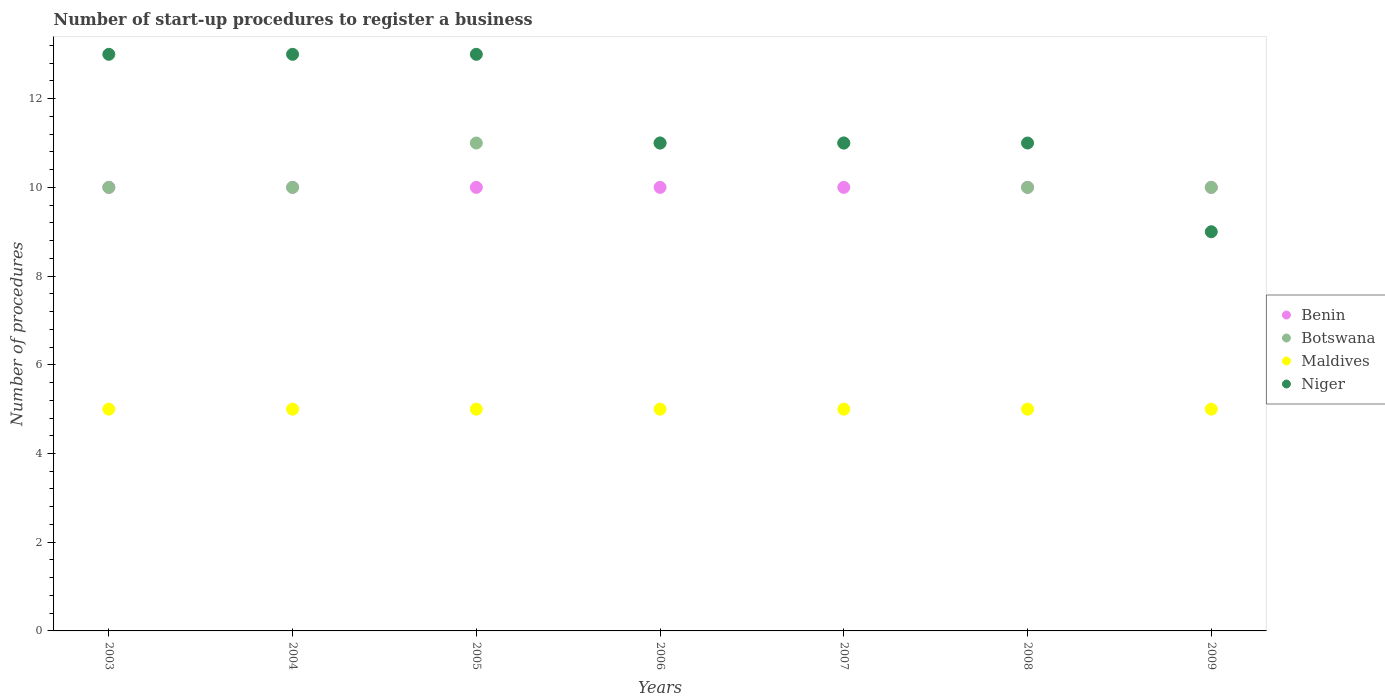Is the number of dotlines equal to the number of legend labels?
Provide a succinct answer. Yes. What is the number of procedures required to register a business in Niger in 2007?
Ensure brevity in your answer.  11. Across all years, what is the maximum number of procedures required to register a business in Niger?
Provide a succinct answer. 13. Across all years, what is the minimum number of procedures required to register a business in Niger?
Offer a terse response. 9. In which year was the number of procedures required to register a business in Maldives maximum?
Your answer should be very brief. 2003. In which year was the number of procedures required to register a business in Maldives minimum?
Provide a short and direct response. 2003. What is the total number of procedures required to register a business in Botswana in the graph?
Provide a short and direct response. 73. What is the difference between the number of procedures required to register a business in Botswana in 2008 and the number of procedures required to register a business in Maldives in 2007?
Provide a short and direct response. 5. What is the average number of procedures required to register a business in Botswana per year?
Your answer should be very brief. 10.43. In the year 2008, what is the difference between the number of procedures required to register a business in Maldives and number of procedures required to register a business in Niger?
Offer a terse response. -6. In how many years, is the number of procedures required to register a business in Maldives greater than 9.2?
Provide a succinct answer. 0. Is the number of procedures required to register a business in Maldives in 2007 less than that in 2009?
Make the answer very short. No. What is the difference between the highest and the lowest number of procedures required to register a business in Benin?
Ensure brevity in your answer.  0. Is it the case that in every year, the sum of the number of procedures required to register a business in Niger and number of procedures required to register a business in Benin  is greater than the number of procedures required to register a business in Maldives?
Ensure brevity in your answer.  Yes. Is the number of procedures required to register a business in Benin strictly greater than the number of procedures required to register a business in Maldives over the years?
Your answer should be very brief. Yes. What is the difference between two consecutive major ticks on the Y-axis?
Provide a succinct answer. 2. Does the graph contain any zero values?
Offer a very short reply. No. Does the graph contain grids?
Ensure brevity in your answer.  No. Where does the legend appear in the graph?
Your answer should be compact. Center right. How many legend labels are there?
Your response must be concise. 4. How are the legend labels stacked?
Provide a succinct answer. Vertical. What is the title of the graph?
Give a very brief answer. Number of start-up procedures to register a business. What is the label or title of the X-axis?
Provide a short and direct response. Years. What is the label or title of the Y-axis?
Offer a very short reply. Number of procedures. What is the Number of procedures of Botswana in 2003?
Give a very brief answer. 10. What is the Number of procedures in Maldives in 2003?
Provide a short and direct response. 5. What is the Number of procedures of Benin in 2004?
Your answer should be very brief. 10. What is the Number of procedures in Maldives in 2004?
Provide a short and direct response. 5. What is the Number of procedures of Benin in 2005?
Provide a short and direct response. 10. What is the Number of procedures in Botswana in 2005?
Ensure brevity in your answer.  11. What is the Number of procedures in Maldives in 2005?
Make the answer very short. 5. What is the Number of procedures in Botswana in 2006?
Give a very brief answer. 11. What is the Number of procedures of Niger in 2006?
Your response must be concise. 11. What is the Number of procedures in Botswana in 2007?
Offer a very short reply. 11. What is the Number of procedures of Maldives in 2007?
Keep it short and to the point. 5. What is the Number of procedures of Benin in 2008?
Make the answer very short. 10. What is the Number of procedures of Niger in 2008?
Your answer should be very brief. 11. What is the Number of procedures in Niger in 2009?
Your response must be concise. 9. Across all years, what is the maximum Number of procedures of Benin?
Ensure brevity in your answer.  10. Across all years, what is the minimum Number of procedures of Botswana?
Keep it short and to the point. 10. Across all years, what is the minimum Number of procedures of Maldives?
Your response must be concise. 5. What is the total Number of procedures of Benin in the graph?
Provide a short and direct response. 70. What is the total Number of procedures of Botswana in the graph?
Keep it short and to the point. 73. What is the total Number of procedures of Maldives in the graph?
Offer a terse response. 35. What is the total Number of procedures in Niger in the graph?
Offer a terse response. 81. What is the difference between the Number of procedures of Botswana in 2003 and that in 2004?
Offer a very short reply. 0. What is the difference between the Number of procedures in Niger in 2003 and that in 2004?
Your response must be concise. 0. What is the difference between the Number of procedures in Benin in 2003 and that in 2005?
Your response must be concise. 0. What is the difference between the Number of procedures of Benin in 2003 and that in 2006?
Ensure brevity in your answer.  0. What is the difference between the Number of procedures of Botswana in 2003 and that in 2006?
Ensure brevity in your answer.  -1. What is the difference between the Number of procedures in Maldives in 2003 and that in 2007?
Keep it short and to the point. 0. What is the difference between the Number of procedures in Benin in 2003 and that in 2008?
Provide a succinct answer. 0. What is the difference between the Number of procedures in Botswana in 2003 and that in 2009?
Provide a succinct answer. 0. What is the difference between the Number of procedures in Maldives in 2003 and that in 2009?
Your answer should be compact. 0. What is the difference between the Number of procedures in Benin in 2004 and that in 2005?
Your answer should be compact. 0. What is the difference between the Number of procedures of Maldives in 2004 and that in 2005?
Your answer should be compact. 0. What is the difference between the Number of procedures of Benin in 2004 and that in 2006?
Offer a terse response. 0. What is the difference between the Number of procedures in Maldives in 2004 and that in 2006?
Make the answer very short. 0. What is the difference between the Number of procedures in Niger in 2004 and that in 2006?
Provide a short and direct response. 2. What is the difference between the Number of procedures in Niger in 2004 and that in 2007?
Make the answer very short. 2. What is the difference between the Number of procedures in Benin in 2004 and that in 2008?
Your response must be concise. 0. What is the difference between the Number of procedures in Botswana in 2004 and that in 2008?
Your answer should be very brief. 0. What is the difference between the Number of procedures of Maldives in 2004 and that in 2008?
Provide a short and direct response. 0. What is the difference between the Number of procedures in Niger in 2004 and that in 2008?
Your response must be concise. 2. What is the difference between the Number of procedures in Benin in 2004 and that in 2009?
Your response must be concise. 0. What is the difference between the Number of procedures in Maldives in 2004 and that in 2009?
Keep it short and to the point. 0. What is the difference between the Number of procedures in Botswana in 2005 and that in 2006?
Your answer should be very brief. 0. What is the difference between the Number of procedures of Benin in 2005 and that in 2008?
Your answer should be very brief. 0. What is the difference between the Number of procedures in Botswana in 2005 and that in 2008?
Keep it short and to the point. 1. What is the difference between the Number of procedures in Maldives in 2005 and that in 2008?
Provide a succinct answer. 0. What is the difference between the Number of procedures in Niger in 2005 and that in 2008?
Offer a very short reply. 2. What is the difference between the Number of procedures of Benin in 2005 and that in 2009?
Offer a terse response. 0. What is the difference between the Number of procedures in Botswana in 2005 and that in 2009?
Your answer should be compact. 1. What is the difference between the Number of procedures in Benin in 2006 and that in 2007?
Keep it short and to the point. 0. What is the difference between the Number of procedures in Maldives in 2006 and that in 2007?
Ensure brevity in your answer.  0. What is the difference between the Number of procedures in Niger in 2006 and that in 2007?
Offer a terse response. 0. What is the difference between the Number of procedures of Maldives in 2006 and that in 2008?
Ensure brevity in your answer.  0. What is the difference between the Number of procedures of Niger in 2006 and that in 2008?
Your answer should be very brief. 0. What is the difference between the Number of procedures of Benin in 2006 and that in 2009?
Offer a terse response. 0. What is the difference between the Number of procedures of Maldives in 2006 and that in 2009?
Make the answer very short. 0. What is the difference between the Number of procedures in Niger in 2006 and that in 2009?
Offer a terse response. 2. What is the difference between the Number of procedures in Botswana in 2007 and that in 2008?
Offer a terse response. 1. What is the difference between the Number of procedures in Benin in 2007 and that in 2009?
Give a very brief answer. 0. What is the difference between the Number of procedures in Botswana in 2008 and that in 2009?
Keep it short and to the point. 0. What is the difference between the Number of procedures of Benin in 2003 and the Number of procedures of Niger in 2004?
Make the answer very short. -3. What is the difference between the Number of procedures in Benin in 2003 and the Number of procedures in Niger in 2005?
Your answer should be compact. -3. What is the difference between the Number of procedures in Botswana in 2003 and the Number of procedures in Maldives in 2005?
Offer a terse response. 5. What is the difference between the Number of procedures of Botswana in 2003 and the Number of procedures of Niger in 2005?
Your response must be concise. -3. What is the difference between the Number of procedures in Maldives in 2003 and the Number of procedures in Niger in 2005?
Your answer should be very brief. -8. What is the difference between the Number of procedures in Benin in 2003 and the Number of procedures in Botswana in 2006?
Keep it short and to the point. -1. What is the difference between the Number of procedures of Benin in 2003 and the Number of procedures of Maldives in 2006?
Offer a very short reply. 5. What is the difference between the Number of procedures of Benin in 2003 and the Number of procedures of Niger in 2006?
Provide a short and direct response. -1. What is the difference between the Number of procedures of Botswana in 2003 and the Number of procedures of Maldives in 2006?
Offer a very short reply. 5. What is the difference between the Number of procedures in Botswana in 2003 and the Number of procedures in Niger in 2006?
Keep it short and to the point. -1. What is the difference between the Number of procedures of Benin in 2003 and the Number of procedures of Botswana in 2007?
Your answer should be compact. -1. What is the difference between the Number of procedures in Benin in 2003 and the Number of procedures in Maldives in 2007?
Provide a short and direct response. 5. What is the difference between the Number of procedures in Botswana in 2003 and the Number of procedures in Maldives in 2007?
Your answer should be compact. 5. What is the difference between the Number of procedures of Maldives in 2003 and the Number of procedures of Niger in 2007?
Provide a succinct answer. -6. What is the difference between the Number of procedures of Benin in 2003 and the Number of procedures of Maldives in 2008?
Keep it short and to the point. 5. What is the difference between the Number of procedures of Benin in 2003 and the Number of procedures of Niger in 2008?
Keep it short and to the point. -1. What is the difference between the Number of procedures of Botswana in 2003 and the Number of procedures of Maldives in 2008?
Provide a short and direct response. 5. What is the difference between the Number of procedures in Maldives in 2003 and the Number of procedures in Niger in 2008?
Offer a very short reply. -6. What is the difference between the Number of procedures of Benin in 2003 and the Number of procedures of Maldives in 2009?
Your answer should be compact. 5. What is the difference between the Number of procedures of Benin in 2003 and the Number of procedures of Niger in 2009?
Your response must be concise. 1. What is the difference between the Number of procedures in Botswana in 2003 and the Number of procedures in Maldives in 2009?
Offer a very short reply. 5. What is the difference between the Number of procedures in Botswana in 2003 and the Number of procedures in Niger in 2009?
Provide a short and direct response. 1. What is the difference between the Number of procedures in Benin in 2004 and the Number of procedures in Maldives in 2005?
Offer a terse response. 5. What is the difference between the Number of procedures of Botswana in 2004 and the Number of procedures of Maldives in 2005?
Provide a succinct answer. 5. What is the difference between the Number of procedures in Maldives in 2004 and the Number of procedures in Niger in 2005?
Ensure brevity in your answer.  -8. What is the difference between the Number of procedures of Benin in 2004 and the Number of procedures of Botswana in 2007?
Provide a short and direct response. -1. What is the difference between the Number of procedures of Benin in 2004 and the Number of procedures of Maldives in 2007?
Provide a short and direct response. 5. What is the difference between the Number of procedures of Benin in 2004 and the Number of procedures of Niger in 2007?
Offer a very short reply. -1. What is the difference between the Number of procedures of Botswana in 2004 and the Number of procedures of Maldives in 2007?
Give a very brief answer. 5. What is the difference between the Number of procedures in Botswana in 2004 and the Number of procedures in Niger in 2007?
Your response must be concise. -1. What is the difference between the Number of procedures in Benin in 2004 and the Number of procedures in Niger in 2008?
Give a very brief answer. -1. What is the difference between the Number of procedures in Benin in 2004 and the Number of procedures in Botswana in 2009?
Ensure brevity in your answer.  0. What is the difference between the Number of procedures of Benin in 2004 and the Number of procedures of Niger in 2009?
Your response must be concise. 1. What is the difference between the Number of procedures of Botswana in 2004 and the Number of procedures of Maldives in 2009?
Your response must be concise. 5. What is the difference between the Number of procedures of Botswana in 2004 and the Number of procedures of Niger in 2009?
Your response must be concise. 1. What is the difference between the Number of procedures of Maldives in 2004 and the Number of procedures of Niger in 2009?
Give a very brief answer. -4. What is the difference between the Number of procedures of Benin in 2005 and the Number of procedures of Botswana in 2006?
Give a very brief answer. -1. What is the difference between the Number of procedures of Botswana in 2005 and the Number of procedures of Maldives in 2006?
Give a very brief answer. 6. What is the difference between the Number of procedures in Maldives in 2005 and the Number of procedures in Niger in 2006?
Offer a terse response. -6. What is the difference between the Number of procedures of Benin in 2005 and the Number of procedures of Maldives in 2007?
Give a very brief answer. 5. What is the difference between the Number of procedures of Benin in 2005 and the Number of procedures of Niger in 2007?
Your response must be concise. -1. What is the difference between the Number of procedures of Botswana in 2005 and the Number of procedures of Maldives in 2007?
Provide a succinct answer. 6. What is the difference between the Number of procedures of Botswana in 2005 and the Number of procedures of Niger in 2007?
Provide a short and direct response. 0. What is the difference between the Number of procedures of Benin in 2005 and the Number of procedures of Botswana in 2008?
Offer a very short reply. 0. What is the difference between the Number of procedures in Benin in 2005 and the Number of procedures in Niger in 2008?
Provide a succinct answer. -1. What is the difference between the Number of procedures in Botswana in 2005 and the Number of procedures in Niger in 2008?
Ensure brevity in your answer.  0. What is the difference between the Number of procedures of Maldives in 2005 and the Number of procedures of Niger in 2008?
Make the answer very short. -6. What is the difference between the Number of procedures of Benin in 2005 and the Number of procedures of Botswana in 2009?
Your response must be concise. 0. What is the difference between the Number of procedures of Benin in 2006 and the Number of procedures of Niger in 2007?
Make the answer very short. -1. What is the difference between the Number of procedures of Maldives in 2006 and the Number of procedures of Niger in 2007?
Give a very brief answer. -6. What is the difference between the Number of procedures of Benin in 2006 and the Number of procedures of Niger in 2008?
Offer a terse response. -1. What is the difference between the Number of procedures of Botswana in 2006 and the Number of procedures of Maldives in 2008?
Offer a terse response. 6. What is the difference between the Number of procedures of Botswana in 2006 and the Number of procedures of Niger in 2008?
Provide a succinct answer. 0. What is the difference between the Number of procedures in Benin in 2006 and the Number of procedures in Botswana in 2009?
Provide a short and direct response. 0. What is the difference between the Number of procedures of Benin in 2006 and the Number of procedures of Maldives in 2009?
Your answer should be compact. 5. What is the difference between the Number of procedures of Benin in 2006 and the Number of procedures of Niger in 2009?
Provide a succinct answer. 1. What is the difference between the Number of procedures in Botswana in 2006 and the Number of procedures in Maldives in 2009?
Ensure brevity in your answer.  6. What is the difference between the Number of procedures in Botswana in 2006 and the Number of procedures in Niger in 2009?
Your answer should be very brief. 2. What is the difference between the Number of procedures in Maldives in 2006 and the Number of procedures in Niger in 2009?
Provide a succinct answer. -4. What is the difference between the Number of procedures of Benin in 2007 and the Number of procedures of Niger in 2008?
Provide a short and direct response. -1. What is the difference between the Number of procedures in Botswana in 2007 and the Number of procedures in Niger in 2008?
Offer a very short reply. 0. What is the difference between the Number of procedures in Benin in 2007 and the Number of procedures in Niger in 2009?
Your response must be concise. 1. What is the difference between the Number of procedures of Botswana in 2007 and the Number of procedures of Niger in 2009?
Provide a succinct answer. 2. What is the difference between the Number of procedures in Benin in 2008 and the Number of procedures in Botswana in 2009?
Your response must be concise. 0. What is the difference between the Number of procedures in Benin in 2008 and the Number of procedures in Niger in 2009?
Give a very brief answer. 1. What is the difference between the Number of procedures of Botswana in 2008 and the Number of procedures of Niger in 2009?
Offer a very short reply. 1. What is the average Number of procedures in Botswana per year?
Keep it short and to the point. 10.43. What is the average Number of procedures of Niger per year?
Your response must be concise. 11.57. In the year 2003, what is the difference between the Number of procedures in Benin and Number of procedures in Botswana?
Offer a very short reply. 0. In the year 2003, what is the difference between the Number of procedures of Benin and Number of procedures of Maldives?
Offer a terse response. 5. In the year 2003, what is the difference between the Number of procedures of Botswana and Number of procedures of Niger?
Offer a very short reply. -3. In the year 2004, what is the difference between the Number of procedures of Benin and Number of procedures of Niger?
Provide a succinct answer. -3. In the year 2004, what is the difference between the Number of procedures of Botswana and Number of procedures of Maldives?
Provide a succinct answer. 5. In the year 2004, what is the difference between the Number of procedures in Maldives and Number of procedures in Niger?
Provide a succinct answer. -8. In the year 2005, what is the difference between the Number of procedures in Benin and Number of procedures in Maldives?
Make the answer very short. 5. In the year 2005, what is the difference between the Number of procedures of Botswana and Number of procedures of Niger?
Provide a short and direct response. -2. In the year 2005, what is the difference between the Number of procedures in Maldives and Number of procedures in Niger?
Your answer should be compact. -8. In the year 2006, what is the difference between the Number of procedures in Benin and Number of procedures in Maldives?
Provide a short and direct response. 5. In the year 2006, what is the difference between the Number of procedures of Botswana and Number of procedures of Maldives?
Keep it short and to the point. 6. In the year 2007, what is the difference between the Number of procedures in Benin and Number of procedures in Maldives?
Offer a very short reply. 5. In the year 2007, what is the difference between the Number of procedures in Benin and Number of procedures in Niger?
Offer a terse response. -1. In the year 2007, what is the difference between the Number of procedures of Botswana and Number of procedures of Maldives?
Give a very brief answer. 6. In the year 2007, what is the difference between the Number of procedures of Botswana and Number of procedures of Niger?
Keep it short and to the point. 0. In the year 2007, what is the difference between the Number of procedures in Maldives and Number of procedures in Niger?
Your answer should be very brief. -6. In the year 2008, what is the difference between the Number of procedures in Benin and Number of procedures in Niger?
Provide a succinct answer. -1. In the year 2009, what is the difference between the Number of procedures in Benin and Number of procedures in Niger?
Keep it short and to the point. 1. In the year 2009, what is the difference between the Number of procedures in Botswana and Number of procedures in Niger?
Ensure brevity in your answer.  1. In the year 2009, what is the difference between the Number of procedures of Maldives and Number of procedures of Niger?
Provide a short and direct response. -4. What is the ratio of the Number of procedures in Benin in 2003 to that in 2004?
Your answer should be very brief. 1. What is the ratio of the Number of procedures of Maldives in 2003 to that in 2004?
Your answer should be compact. 1. What is the ratio of the Number of procedures of Niger in 2003 to that in 2004?
Provide a succinct answer. 1. What is the ratio of the Number of procedures of Maldives in 2003 to that in 2005?
Give a very brief answer. 1. What is the ratio of the Number of procedures of Benin in 2003 to that in 2006?
Make the answer very short. 1. What is the ratio of the Number of procedures of Niger in 2003 to that in 2006?
Keep it short and to the point. 1.18. What is the ratio of the Number of procedures in Maldives in 2003 to that in 2007?
Ensure brevity in your answer.  1. What is the ratio of the Number of procedures of Niger in 2003 to that in 2007?
Your response must be concise. 1.18. What is the ratio of the Number of procedures in Botswana in 2003 to that in 2008?
Ensure brevity in your answer.  1. What is the ratio of the Number of procedures of Niger in 2003 to that in 2008?
Ensure brevity in your answer.  1.18. What is the ratio of the Number of procedures in Benin in 2003 to that in 2009?
Give a very brief answer. 1. What is the ratio of the Number of procedures in Niger in 2003 to that in 2009?
Give a very brief answer. 1.44. What is the ratio of the Number of procedures of Benin in 2004 to that in 2005?
Make the answer very short. 1. What is the ratio of the Number of procedures of Botswana in 2004 to that in 2005?
Keep it short and to the point. 0.91. What is the ratio of the Number of procedures of Maldives in 2004 to that in 2005?
Offer a very short reply. 1. What is the ratio of the Number of procedures of Niger in 2004 to that in 2006?
Provide a short and direct response. 1.18. What is the ratio of the Number of procedures of Benin in 2004 to that in 2007?
Your answer should be compact. 1. What is the ratio of the Number of procedures of Niger in 2004 to that in 2007?
Make the answer very short. 1.18. What is the ratio of the Number of procedures in Botswana in 2004 to that in 2008?
Offer a very short reply. 1. What is the ratio of the Number of procedures in Niger in 2004 to that in 2008?
Your answer should be compact. 1.18. What is the ratio of the Number of procedures of Botswana in 2004 to that in 2009?
Your answer should be very brief. 1. What is the ratio of the Number of procedures of Maldives in 2004 to that in 2009?
Provide a succinct answer. 1. What is the ratio of the Number of procedures of Niger in 2004 to that in 2009?
Provide a succinct answer. 1.44. What is the ratio of the Number of procedures in Botswana in 2005 to that in 2006?
Offer a very short reply. 1. What is the ratio of the Number of procedures in Niger in 2005 to that in 2006?
Provide a short and direct response. 1.18. What is the ratio of the Number of procedures of Benin in 2005 to that in 2007?
Ensure brevity in your answer.  1. What is the ratio of the Number of procedures in Niger in 2005 to that in 2007?
Offer a terse response. 1.18. What is the ratio of the Number of procedures of Benin in 2005 to that in 2008?
Offer a terse response. 1. What is the ratio of the Number of procedures of Maldives in 2005 to that in 2008?
Offer a very short reply. 1. What is the ratio of the Number of procedures in Niger in 2005 to that in 2008?
Provide a short and direct response. 1.18. What is the ratio of the Number of procedures of Maldives in 2005 to that in 2009?
Your answer should be compact. 1. What is the ratio of the Number of procedures of Niger in 2005 to that in 2009?
Your answer should be very brief. 1.44. What is the ratio of the Number of procedures of Niger in 2006 to that in 2007?
Your response must be concise. 1. What is the ratio of the Number of procedures of Benin in 2006 to that in 2008?
Your answer should be very brief. 1. What is the ratio of the Number of procedures in Botswana in 2006 to that in 2008?
Offer a very short reply. 1.1. What is the ratio of the Number of procedures in Maldives in 2006 to that in 2008?
Provide a succinct answer. 1. What is the ratio of the Number of procedures of Niger in 2006 to that in 2009?
Ensure brevity in your answer.  1.22. What is the ratio of the Number of procedures of Benin in 2007 to that in 2008?
Keep it short and to the point. 1. What is the ratio of the Number of procedures in Botswana in 2007 to that in 2008?
Ensure brevity in your answer.  1.1. What is the ratio of the Number of procedures in Maldives in 2007 to that in 2008?
Your answer should be compact. 1. What is the ratio of the Number of procedures of Niger in 2007 to that in 2008?
Give a very brief answer. 1. What is the ratio of the Number of procedures in Niger in 2007 to that in 2009?
Your answer should be compact. 1.22. What is the ratio of the Number of procedures of Benin in 2008 to that in 2009?
Provide a succinct answer. 1. What is the ratio of the Number of procedures in Botswana in 2008 to that in 2009?
Keep it short and to the point. 1. What is the ratio of the Number of procedures of Niger in 2008 to that in 2009?
Your answer should be very brief. 1.22. What is the difference between the highest and the second highest Number of procedures in Botswana?
Provide a succinct answer. 0. What is the difference between the highest and the second highest Number of procedures of Maldives?
Your answer should be very brief. 0. 